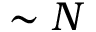Convert formula to latex. <formula><loc_0><loc_0><loc_500><loc_500>\sim N</formula> 